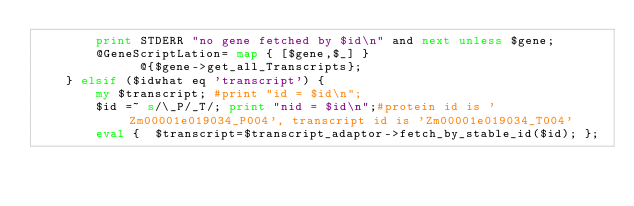Convert code to text. <code><loc_0><loc_0><loc_500><loc_500><_Perl_>	    print STDERR "no gene fetched by $id\n" and next unless $gene;
	    @GeneScriptLation= map { [$gene,$_] }
		      @{$gene->get_all_Transcripts};
	} elsif ($idwhat eq 'transcript') {
	    my $transcript; #print "id = $id\n";
	    $id =~ s/\_P/_T/; print "nid = $id\n";#protein id is 'Zm00001e019034_P004', transcript id is 'Zm00001e019034_T004'
	    eval {  $transcript=$transcript_adaptor->fetch_by_stable_id($id); };</code> 